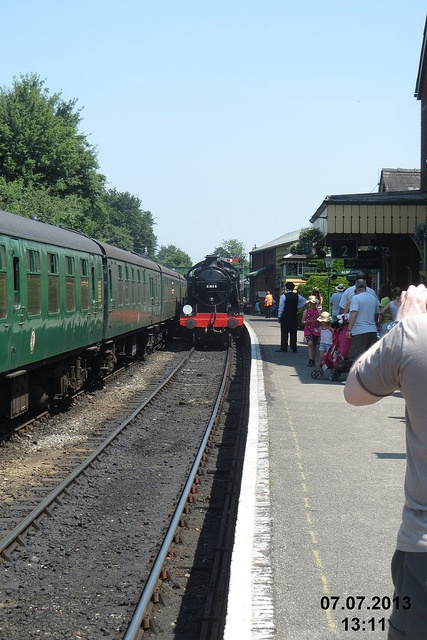Describe the objects in this image and their specific colors. I can see train in lightblue, black, gray, darkgreen, and darkgray tones, people in lightblue, gray, black, darkgray, and lightgray tones, train in lightblue, black, gray, and brown tones, people in lightblue, black, and gray tones, and people in lightblue, black, gray, and darkblue tones in this image. 